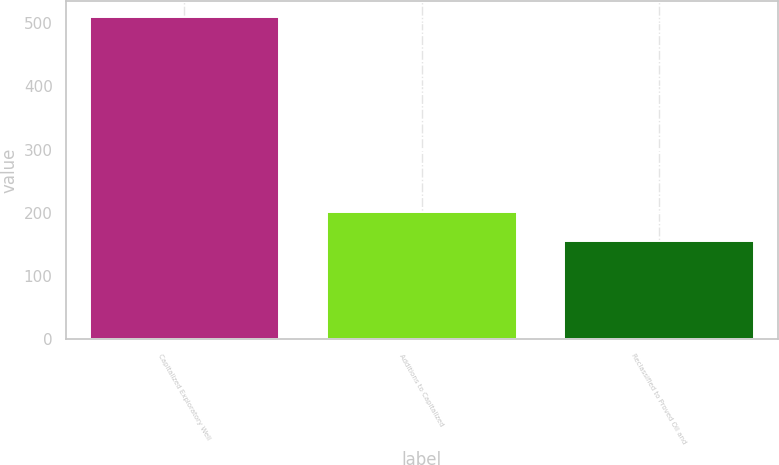<chart> <loc_0><loc_0><loc_500><loc_500><bar_chart><fcel>Capitalized Exploratory Well<fcel>Additions to Capitalized<fcel>Reclassified to Proved Oil and<nl><fcel>509.3<fcel>201.3<fcel>155<nl></chart> 